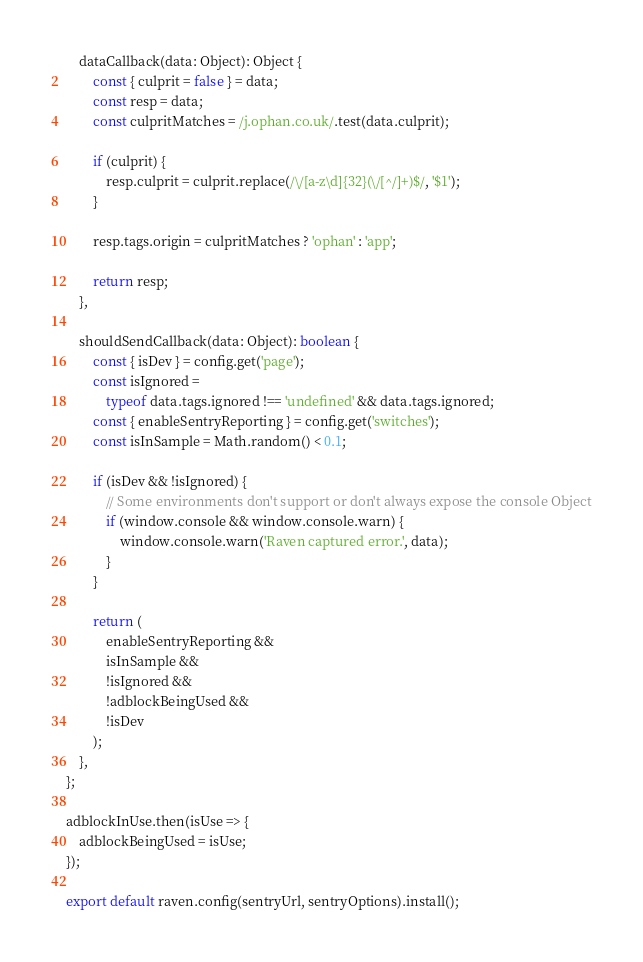<code> <loc_0><loc_0><loc_500><loc_500><_JavaScript_>    dataCallback(data: Object): Object {
        const { culprit = false } = data;
        const resp = data;
        const culpritMatches = /j.ophan.co.uk/.test(data.culprit);

        if (culprit) {
            resp.culprit = culprit.replace(/\/[a-z\d]{32}(\/[^/]+)$/, '$1');
        }

        resp.tags.origin = culpritMatches ? 'ophan' : 'app';

        return resp;
    },

    shouldSendCallback(data: Object): boolean {
        const { isDev } = config.get('page');
        const isIgnored =
            typeof data.tags.ignored !== 'undefined' && data.tags.ignored;
        const { enableSentryReporting } = config.get('switches');
        const isInSample = Math.random() < 0.1;

        if (isDev && !isIgnored) {
            // Some environments don't support or don't always expose the console Object
            if (window.console && window.console.warn) {
                window.console.warn('Raven captured error.', data);
            }
        }

        return (
            enableSentryReporting &&
            isInSample &&
            !isIgnored &&
            !adblockBeingUsed &&
            !isDev
        );
    },
};

adblockInUse.then(isUse => {
    adblockBeingUsed = isUse;
});

export default raven.config(sentryUrl, sentryOptions).install();
</code> 